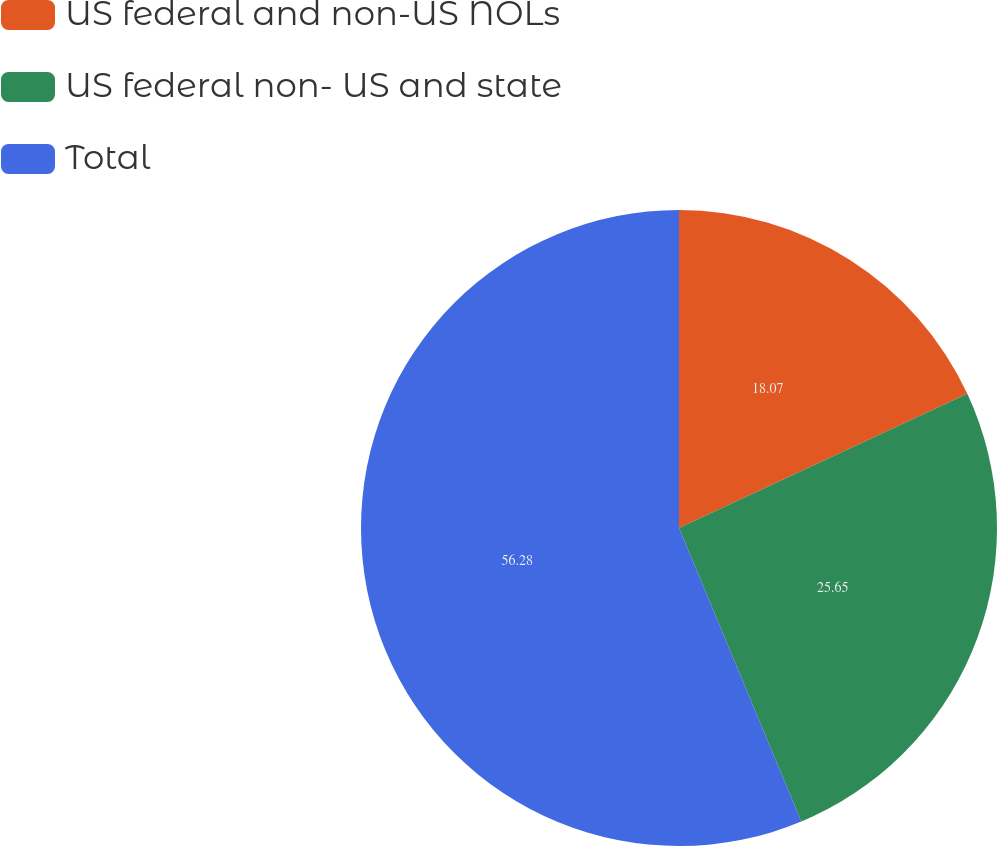Convert chart to OTSL. <chart><loc_0><loc_0><loc_500><loc_500><pie_chart><fcel>US federal and non-US NOLs<fcel>US federal non- US and state<fcel>Total<nl><fcel>18.07%<fcel>25.65%<fcel>56.28%<nl></chart> 